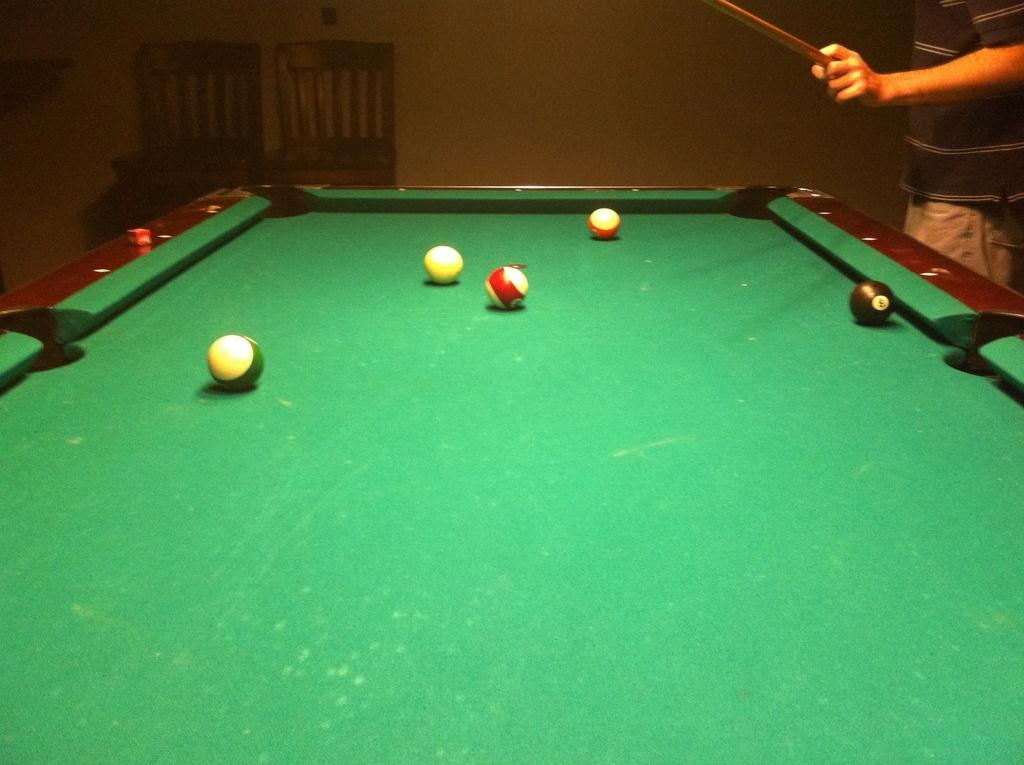What game is being played in the image? There is a snooker board in the image, so the game being played is snooker. What objects are on the snooker board? There are balls on the snooker board. Who is playing the game in the image? There is a man with a striking pole in the image, so he is playing the game. Where is the man positioned in relation to the snooker board? The man is standing on the right side of the snooker board. What can be seen in the background of the image? There are two chairs in the background of the image. What type of finger can be seen cutting the snooker balls in the image? There are no fingers or scissors present in the image; it features a snooker board with balls and a man holding a striking pole. 